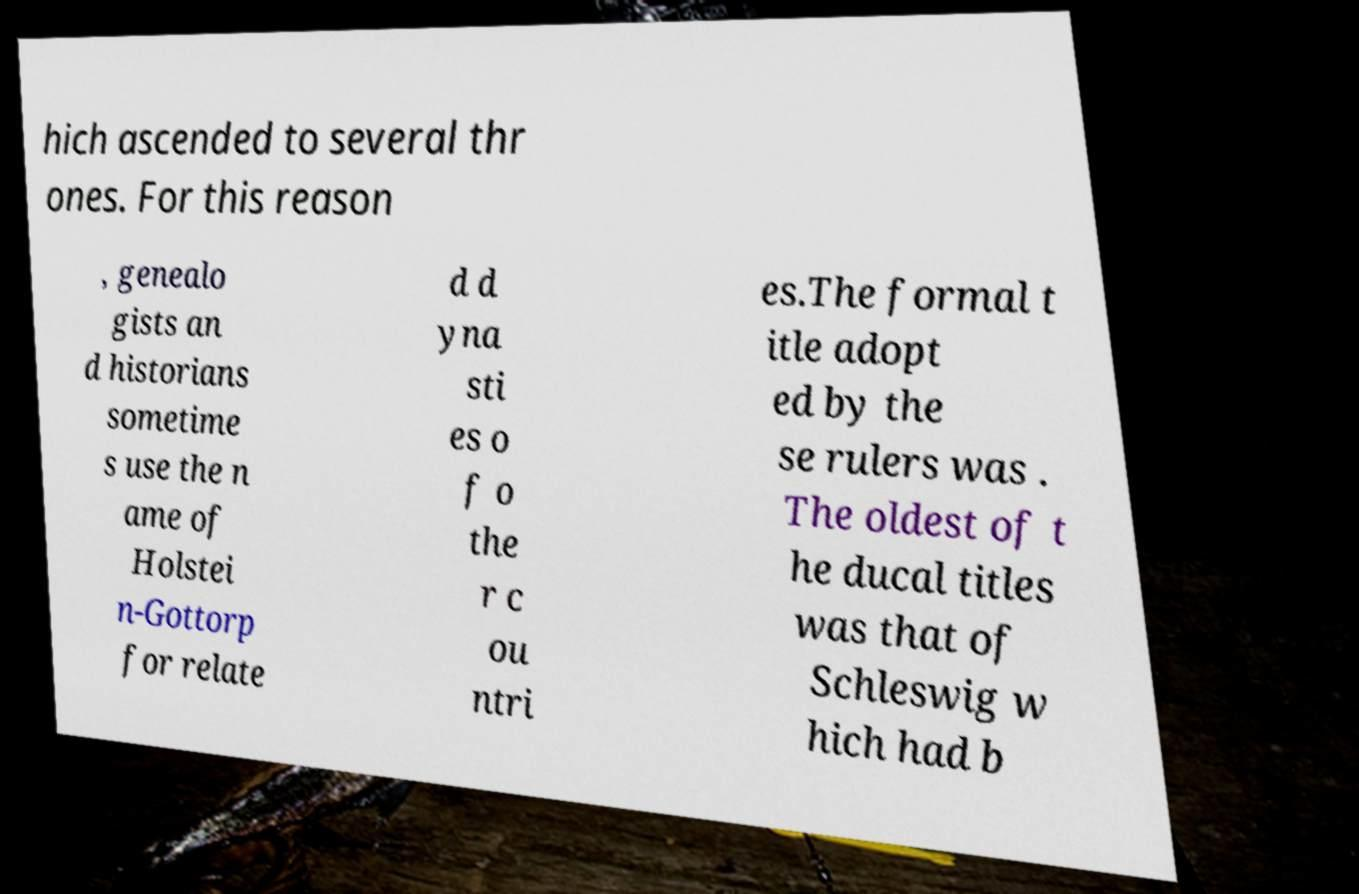Could you extract and type out the text from this image? hich ascended to several thr ones. For this reason , genealo gists an d historians sometime s use the n ame of Holstei n-Gottorp for relate d d yna sti es o f o the r c ou ntri es.The formal t itle adopt ed by the se rulers was . The oldest of t he ducal titles was that of Schleswig w hich had b 